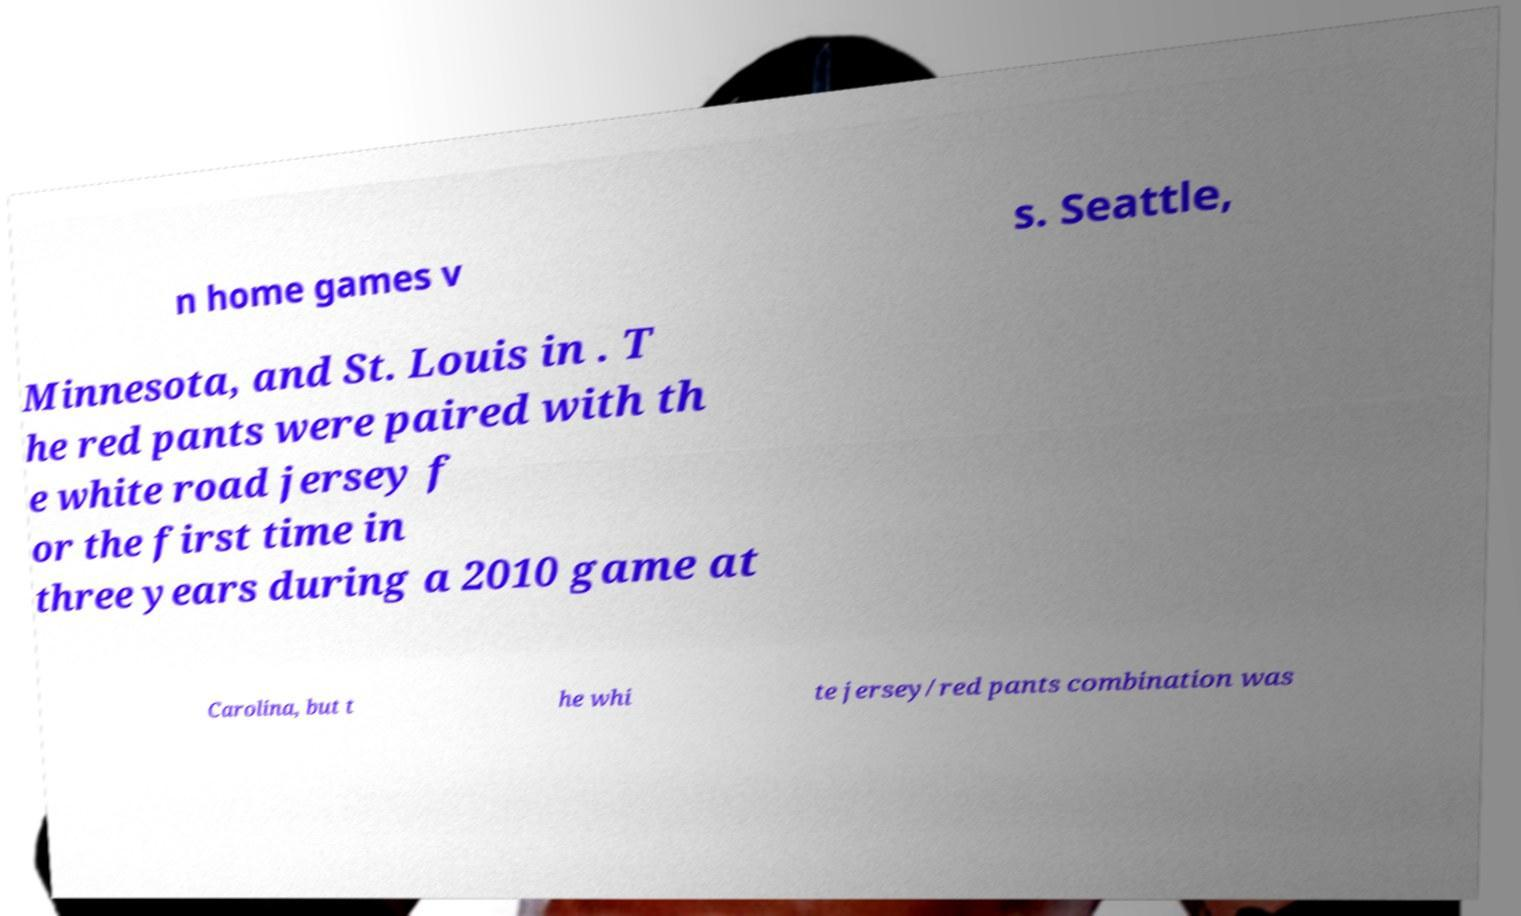Can you read and provide the text displayed in the image?This photo seems to have some interesting text. Can you extract and type it out for me? n home games v s. Seattle, Minnesota, and St. Louis in . T he red pants were paired with th e white road jersey f or the first time in three years during a 2010 game at Carolina, but t he whi te jersey/red pants combination was 